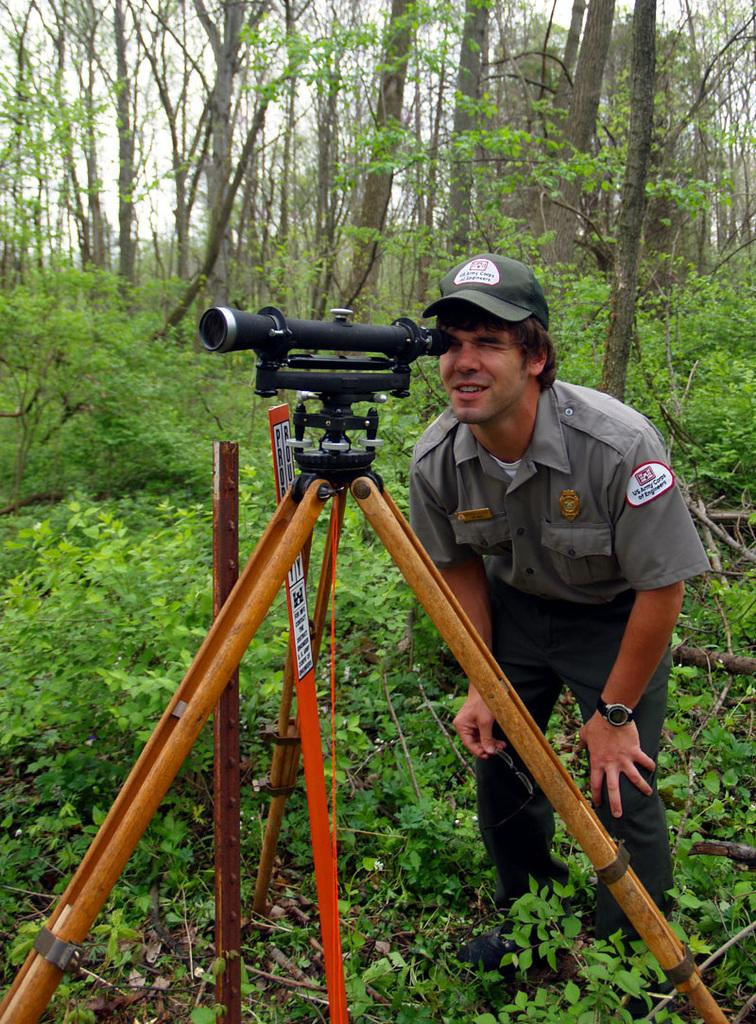What is present in the image? There is a person, grass, plants, a pole, a black color object on a stand, trees, and the sky is visible in the image. Can you describe the person in the image? The provided facts do not give any details about the person's appearance or actions. What type of ground is visible in the image? The ground in the image has grass. What can be seen on the stand in the image? There is a black color object on a stand in the image. What is the natural environment like in the image? The natural environment includes grass, plants, and trees. What is visible in the sky in the image? The sky is visible in the image, but no specific details about the sky are provided. How does the flame blow in the image? There is no flame present in the image. What type of question is being asked in the image? There is no question being asked in the image. 